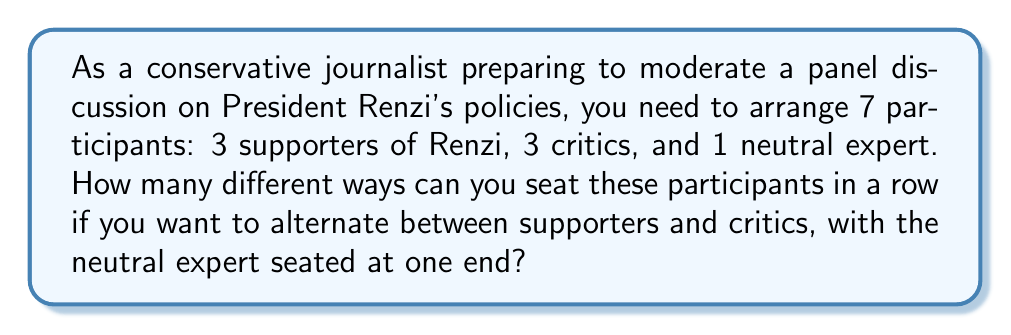Help me with this question. Let's approach this step-by-step:

1) First, we need to decide which end the neutral expert will sit. There are 2 choices for this.

2) Once the neutral expert is placed, we have 6 seats left to fill, alternating between supporters and critics.

3) We can think of this as filling 3 supporter positions and 3 critic positions.

4) For the supporter positions, we have 3 choices for the first position, 2 for the second, and 1 for the last. This gives us $3! = 3 \times 2 \times 1 = 6$ ways to arrange the supporters.

5) Similarly, for the critics, we also have $3! = 6$ ways to arrange them.

6) By the multiplication principle, for each arrangement of supporters, we can have any arrangement of critics. So we multiply these: $6 \times 6 = 36$.

7) However, remember that we have 2 choices for the neutral expert's position. So we need to double our result.

8) Therefore, the total number of arrangements is:

   $$2 \times 3! \times 3! = 2 \times 6 \times 6 = 72$$

This calculation ensures a balanced representation of viewpoints, which is crucial for a conservative journalist aiming to present a fair debate on President Renzi's policies.
Answer: 72 different arrangements 